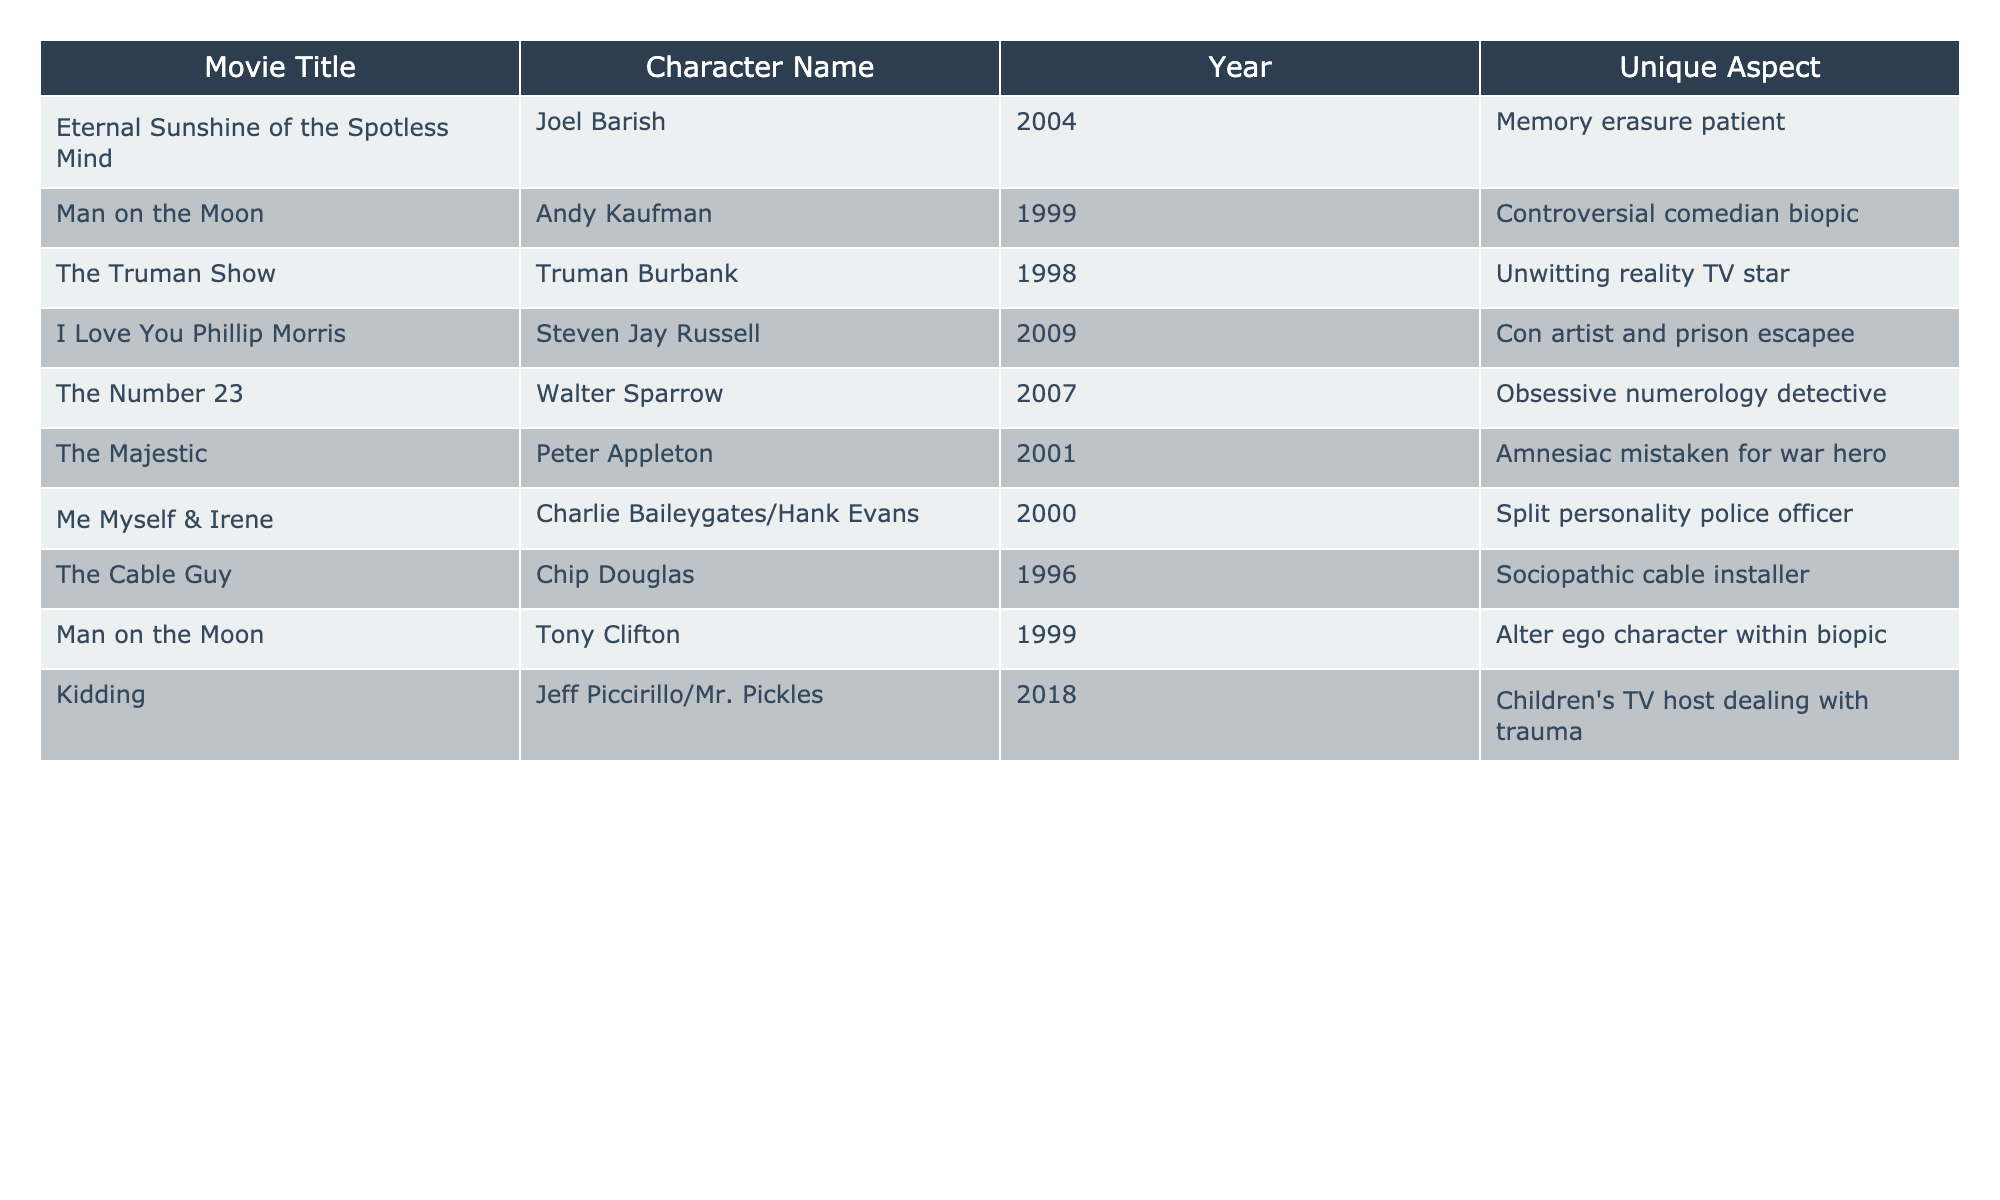What is the title of the movie where the character is a memory erasure patient? The table lists the movie titles along with the character names. By scanning the table for "memory erasure patient," I find it corresponds to "Eternal Sunshine of the Spotless Mind."
Answer: Eternal Sunshine of the Spotless Mind Which character is a con artist and prison escapee? Looking across the table, I identify "I Love You Phillip Morris" as the movie, and the character's name is "Steven Jay Russell."
Answer: Steven Jay Russell How many roles are listed in the table? The table contains 10 entries, each representing a different role played by the actor.
Answer: 10 What is the unique aspect of the character from "The Number 23"? The unique aspect is mentioned in the table under the "Unique Aspect" column for that title, which indicates that the character is an "Obsessive numerology detective."
Answer: Obsessive numerology detective In which year did the character dealing with trauma in a children’s TV show appear? By checking the table, I see that "Kidding" features the character "Jeff Piccirillo/Mr. Pickles," which was released in 2018.
Answer: 2018 Is there a character that has a split personality? The table shows that the movie "Me Myself & Irene" features a character with a split personality, as indicated specifically in the unique aspect.
Answer: Yes Which two movies feature the character Andy Kaufman? Looking through the table, I note that the character "Andy Kaufman" appears in "Man on the Moon." The same movie is listed twice as it has two unique roles related to the character.
Answer: Man on the Moon What is the average year of release for the movies listed? To calculate the average, I sum the years (2004 + 1999 + 1998 + 2009 + 2007 + 2001 + 2000 + 1996 + 1999 + 2018 = 2002.1). There are 10 movies, so the average year is 2002.1 (rounded to 2002).
Answer: 2002 Which character is mistaken for a war hero? The table specifies that "Peter Appleton" from "The Majestic" is known as an amnesiac mistaken for a war hero.
Answer: Peter Appleton What is the unique aspect of the character played in "The Truman Show"? In the related entry, the unique aspect for Truman Burbank in "The Truman Show" is that he is an "Unwitting reality TV star."
Answer: Unwitting reality TV star 